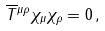Convert formula to latex. <formula><loc_0><loc_0><loc_500><loc_500>\overline { T } { ^ { \mu \rho } } \chi _ { \mu } \chi _ { \rho } = 0 \, ,</formula> 